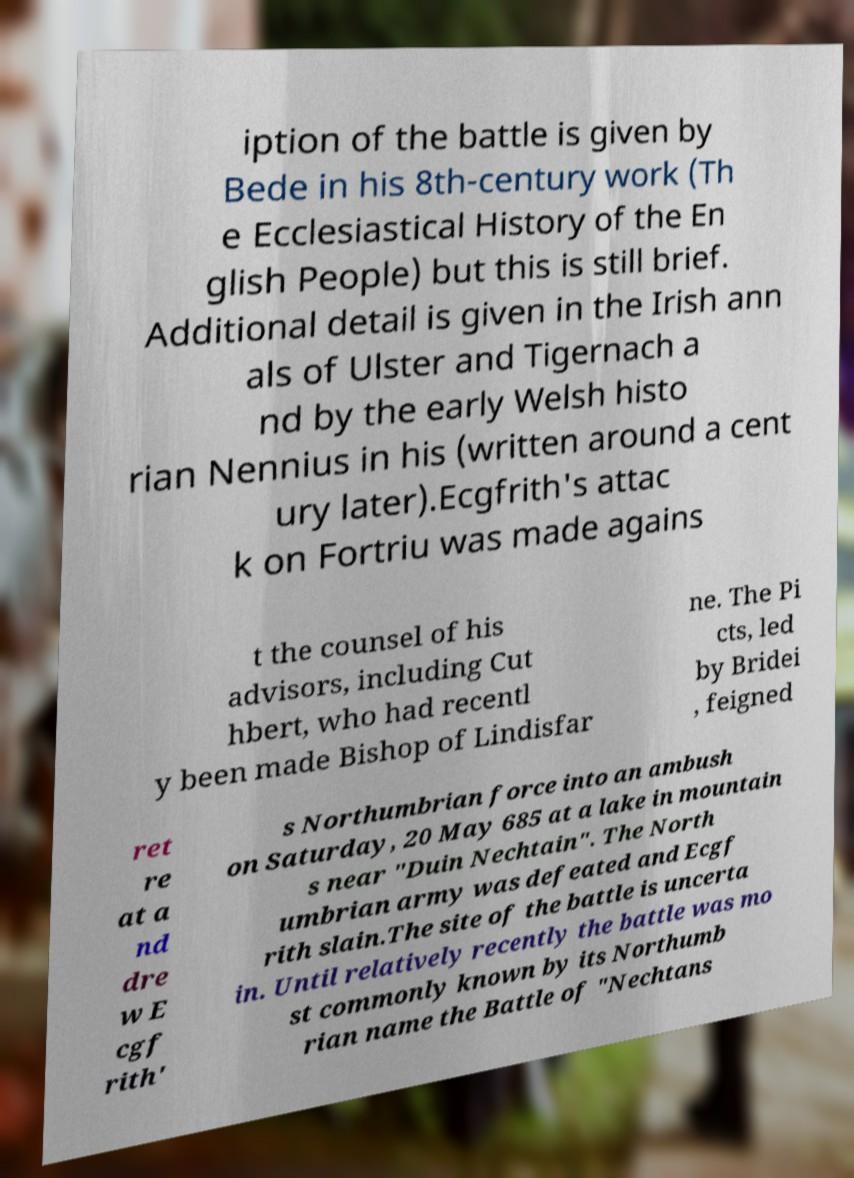There's text embedded in this image that I need extracted. Can you transcribe it verbatim? iption of the battle is given by Bede in his 8th-century work (Th e Ecclesiastical History of the En glish People) but this is still brief. Additional detail is given in the Irish ann als of Ulster and Tigernach a nd by the early Welsh histo rian Nennius in his (written around a cent ury later).Ecgfrith's attac k on Fortriu was made agains t the counsel of his advisors, including Cut hbert, who had recentl y been made Bishop of Lindisfar ne. The Pi cts, led by Bridei , feigned ret re at a nd dre w E cgf rith' s Northumbrian force into an ambush on Saturday, 20 May 685 at a lake in mountain s near "Duin Nechtain". The North umbrian army was defeated and Ecgf rith slain.The site of the battle is uncerta in. Until relatively recently the battle was mo st commonly known by its Northumb rian name the Battle of "Nechtans 